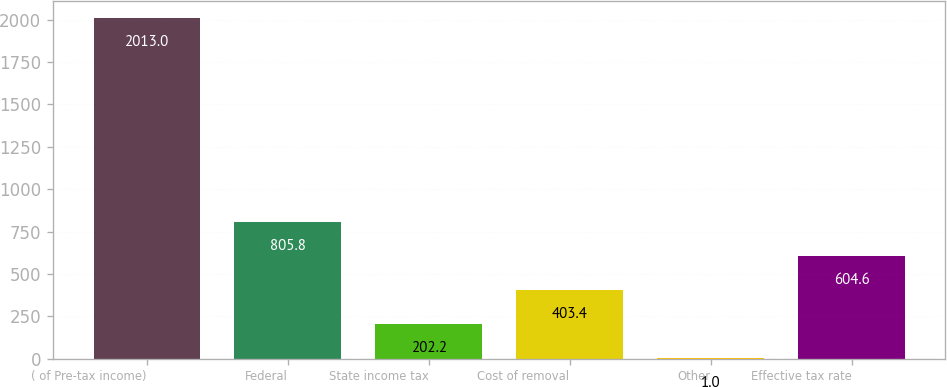<chart> <loc_0><loc_0><loc_500><loc_500><bar_chart><fcel>( of Pre-tax income)<fcel>Federal<fcel>State income tax<fcel>Cost of removal<fcel>Other<fcel>Effective tax rate<nl><fcel>2013<fcel>805.8<fcel>202.2<fcel>403.4<fcel>1<fcel>604.6<nl></chart> 